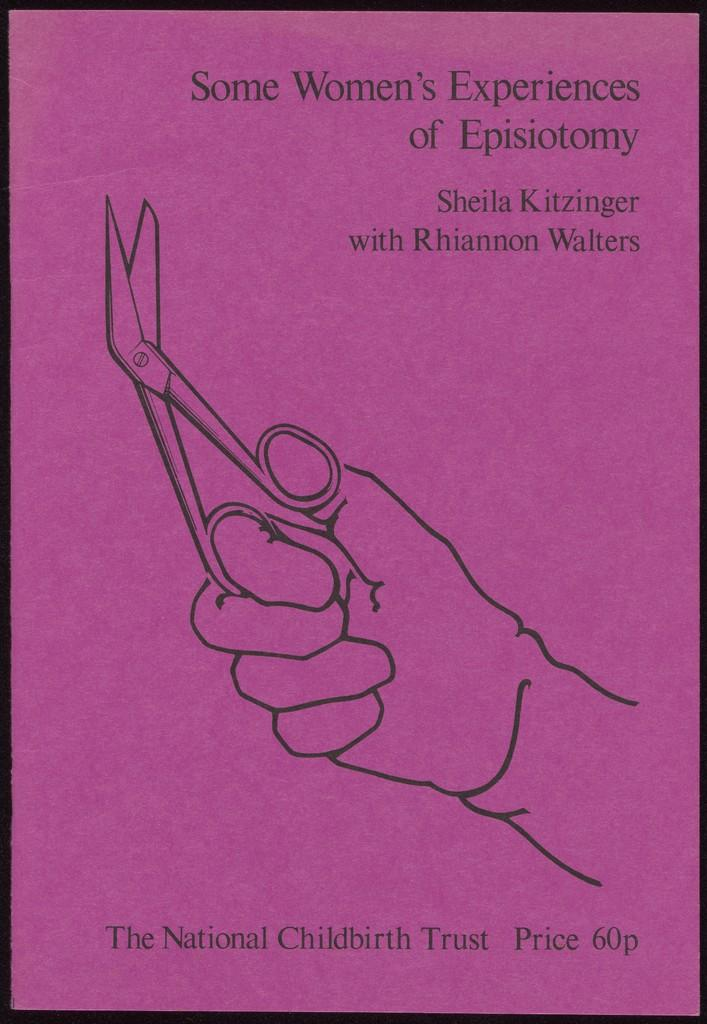<image>
Describe the image concisely. Poster showing a person holding a pair of scissors and the words "Some Women's experiences of Episiotomy". 